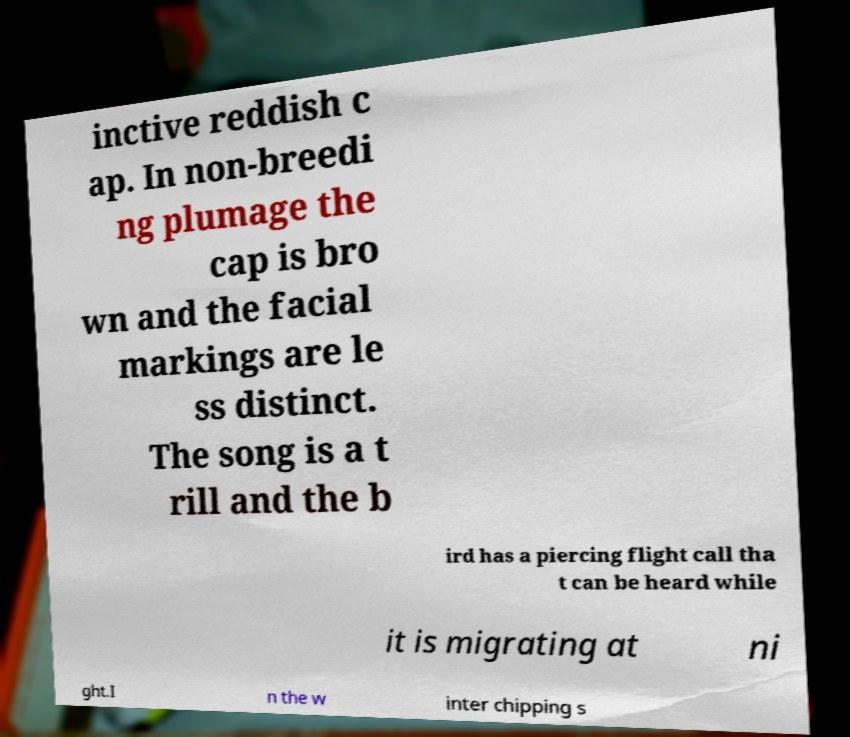Please read and relay the text visible in this image. What does it say? inctive reddish c ap. In non-breedi ng plumage the cap is bro wn and the facial markings are le ss distinct. The song is a t rill and the b ird has a piercing flight call tha t can be heard while it is migrating at ni ght.I n the w inter chipping s 